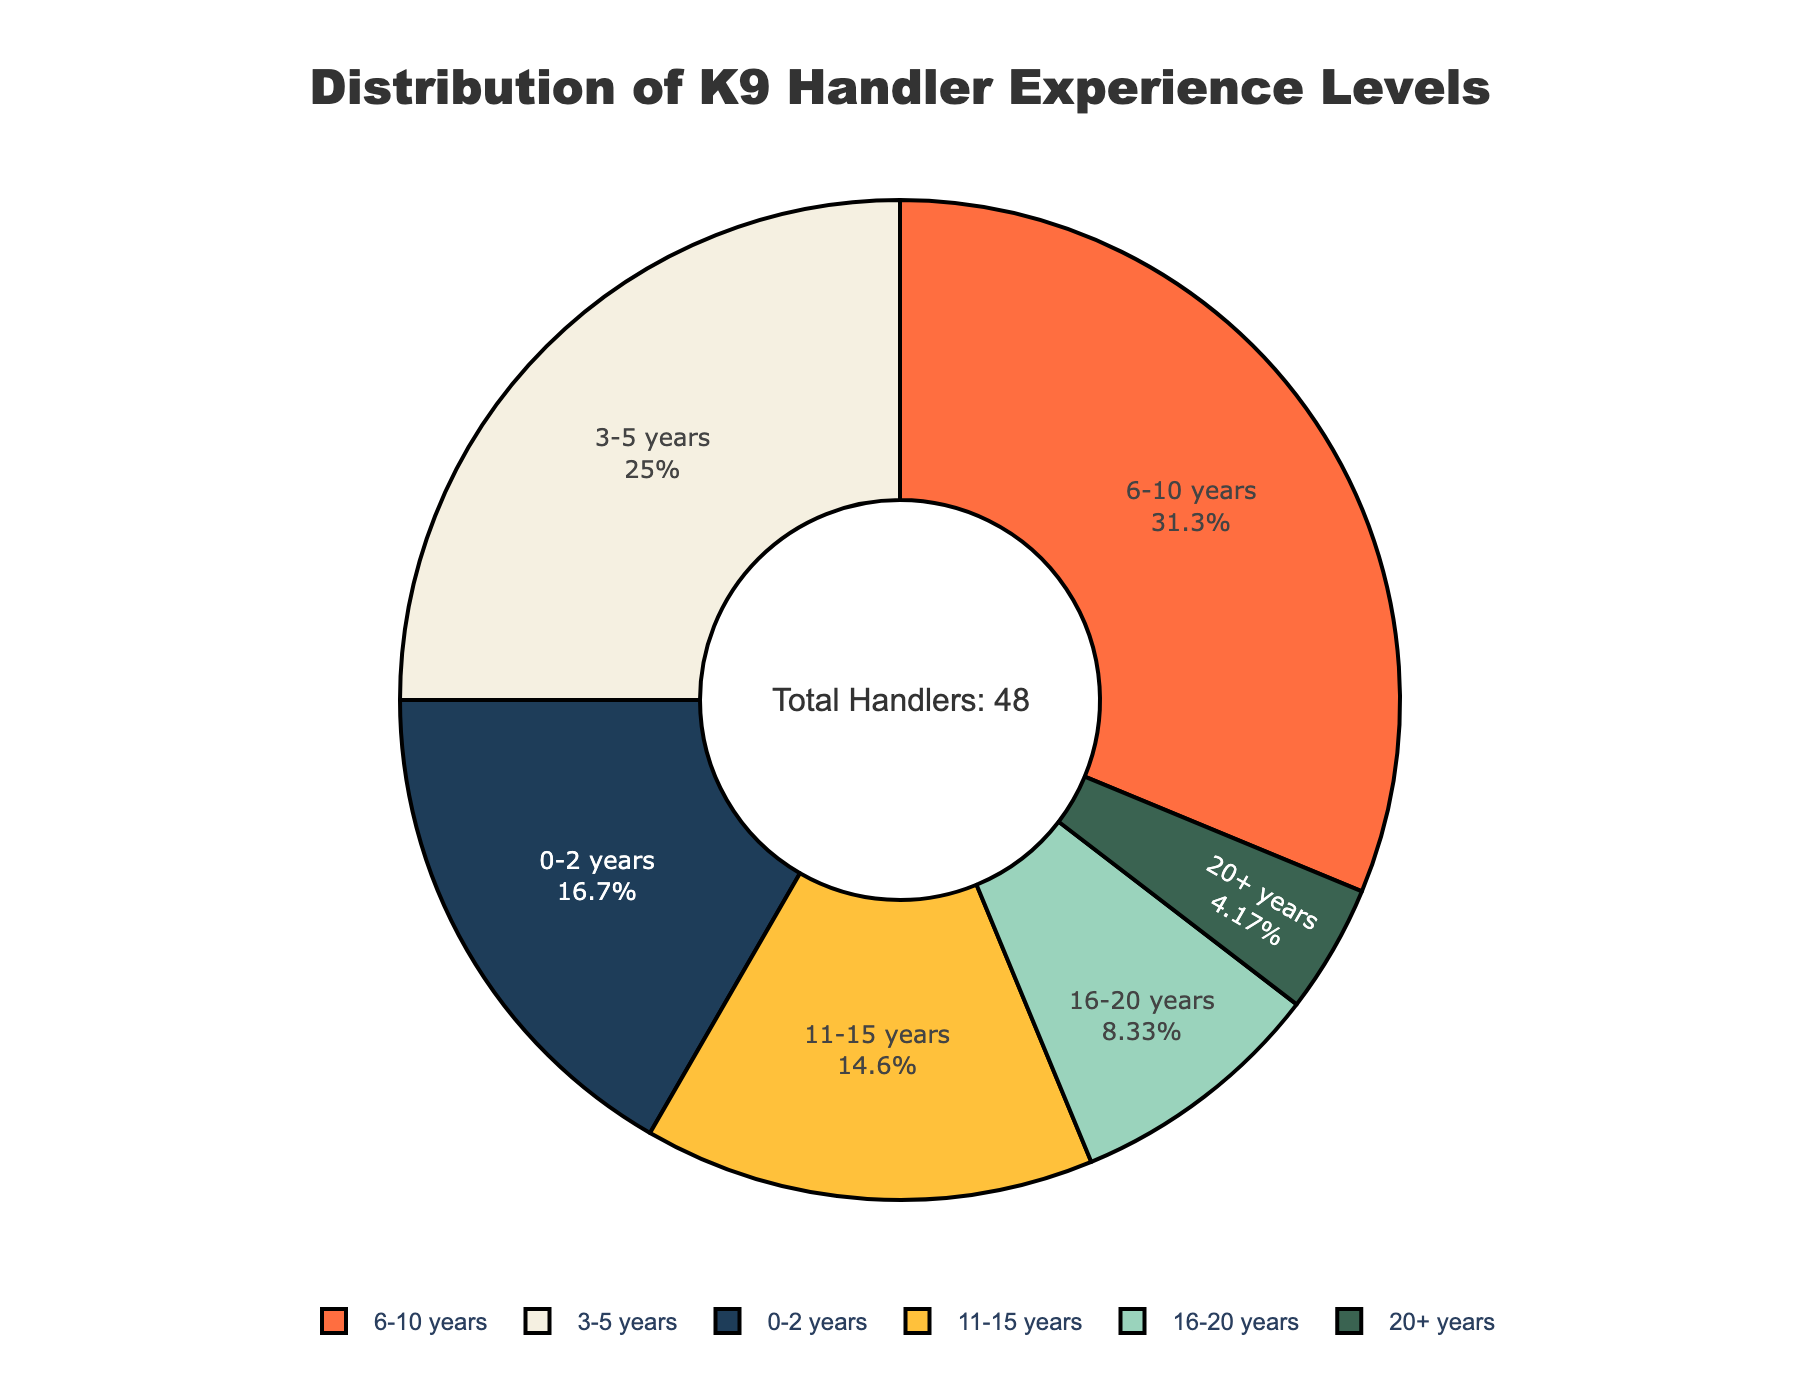What percentage of K9 handlers have 0-2 years of experience? Look at the pie chart segment labeled "0-2 years" and read the percentage value displayed inside that segment.
Answer: 17.0% Which experience level has the largest number of K9 handlers? Find the segment in the pie chart with the largest area and check its label to identify the experience level. The percentage inside the segment also indicates a higher value.
Answer: 6-10 years How does the number of handlers with 3-5 years of experience compare to those with 16-20 years of experience? Check the number of handlers in both segments on the pie chart. The "3-5 years" segment has 12 handlers, while the "16-20 years" segment has 4 handlers.
Answer: 3-5 years has more handlers What is the combined percentage of K9 handlers with over 10 years of experience? Add the percentages of the "11-15 years," "16-20 years," and "20+ years" segments from the pie chart: 11.5% + 6.6% + 3.3% = 21.4%.
Answer: 21.4% Which segment is visually the smallest, and what does it represent in terms of experience? Identify the smallest segment by the area it covers on the pie chart and check the label.
Answer: 20+ years What is the difference in the number of handlers between those with 0-2 years and those with 6-10 years of experience? Subtract the number of handlers for the "0-2 years" segment (8) from the "6-10 years" segment (15): 15 - 8 = 7.
Answer: 7 How many more handlers have 3-5 years of experience compared to those with 20+ years? Subtract the number of handlers in the "20+ years" segment (2) from the number in the "3-5 years" segment (12): 12 - 2 = 10.
Answer: 10 What proportion of handlers have less than 6 years of experience? Add the percentages for the "0-2 years" and "3-5 years" segments: 17.0% + 25.5% = 42.5%.
Answer: 42.5% How does the experience level of handlers distribute in terms of colors? Identify and describe the color associated with each experience level by looking at the pie chart.
Answer: Various colors (e.g., dark blue, white, bright orange, yellow, light green, dark green) What is the total number of handlers shown in the pie chart? Check the annotation in the center of the pie chart that states the total number of handlers: 48.
Answer: 48 